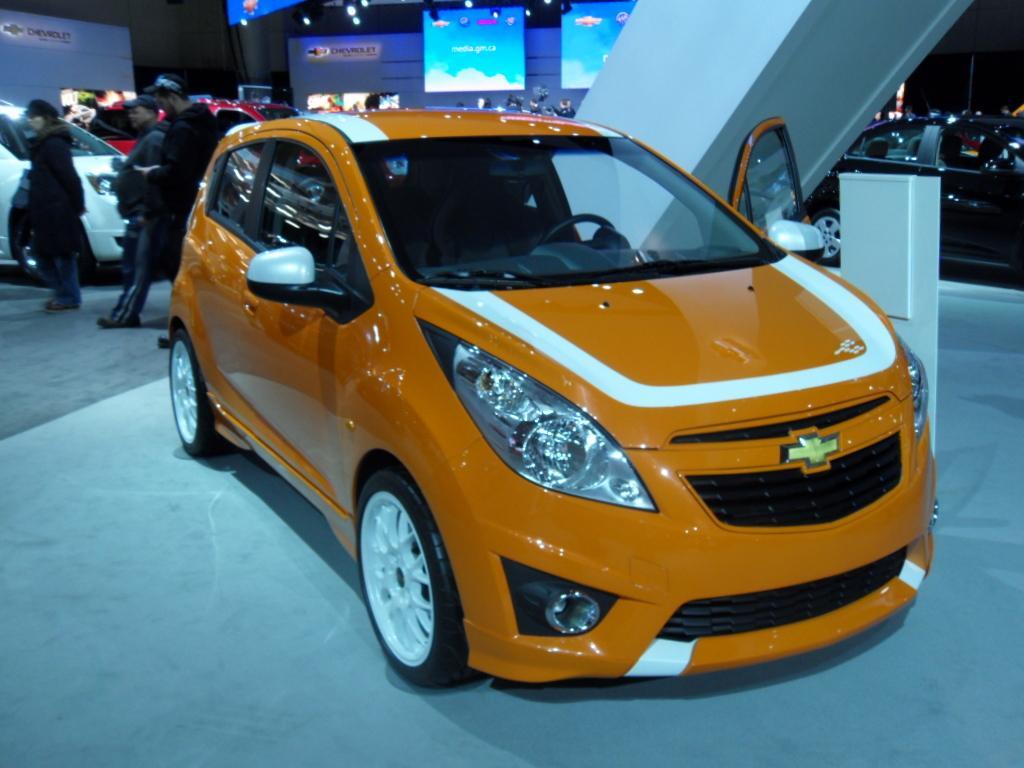Describe this image in one or two sentences. In this image I can see number of cars and on the left side I can see three persons are standing. In the background I can see few boards and number of lights. 